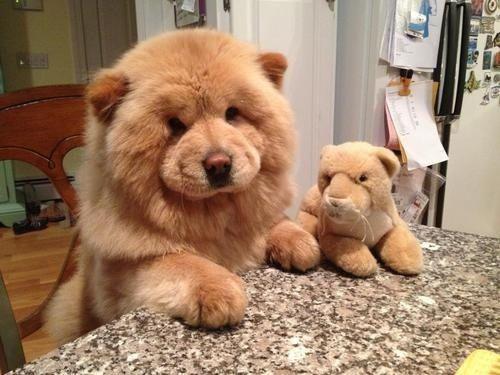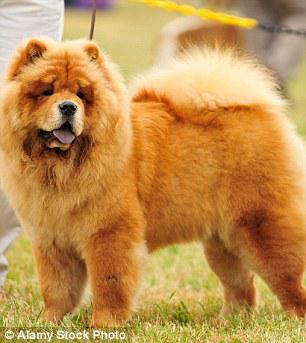The first image is the image on the left, the second image is the image on the right. Analyze the images presented: Is the assertion "The right image contains exactly two chow dogs." valid? Answer yes or no. No. The first image is the image on the left, the second image is the image on the right. Analyze the images presented: Is the assertion "There are 4 chows in the image pair" valid? Answer yes or no. No. 